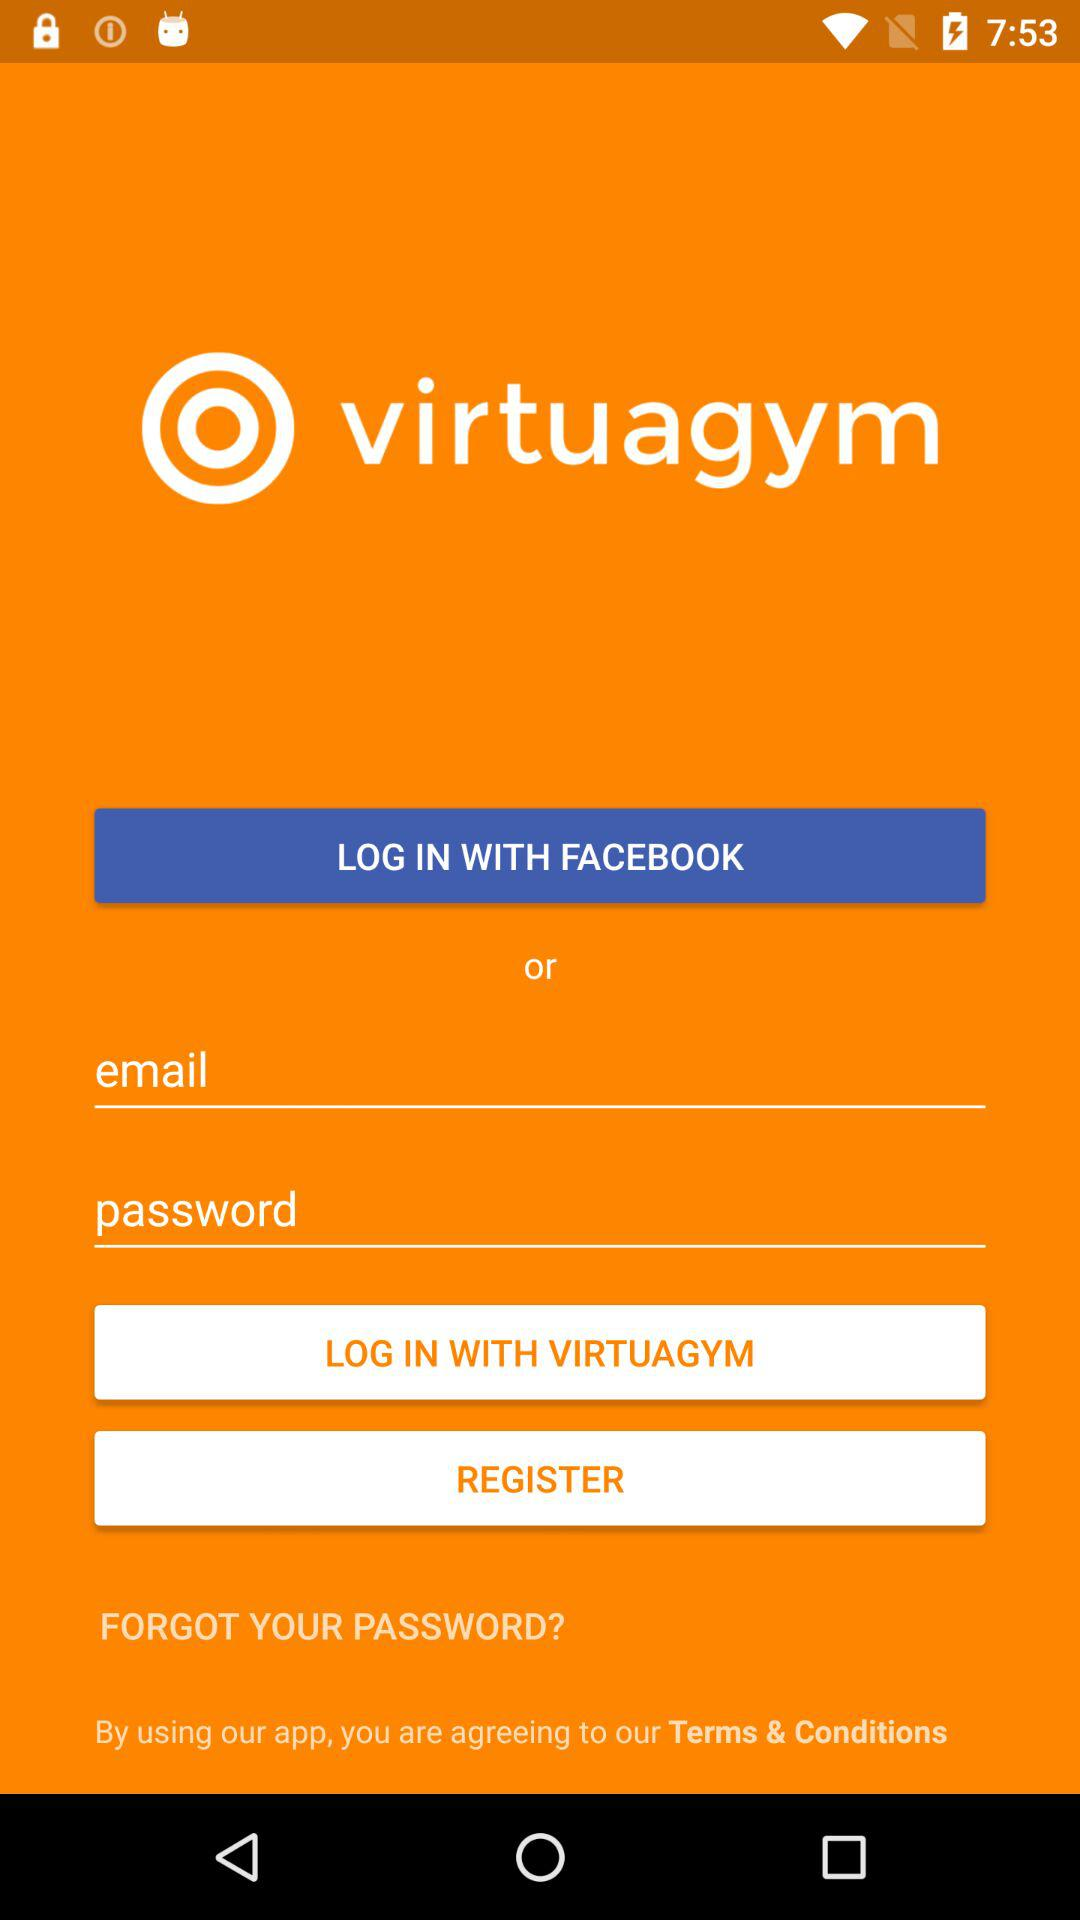What are the different options through which we can log in? The different options are "FACEBOOK" and "VIRTUAGYM". 